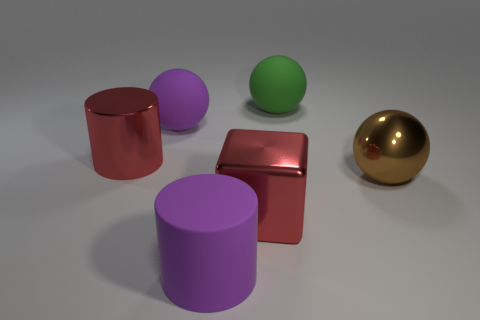Add 4 red cylinders. How many objects exist? 10 Subtract all blocks. How many objects are left? 5 Subtract all big metal cylinders. Subtract all large purple cylinders. How many objects are left? 4 Add 3 brown shiny things. How many brown shiny things are left? 4 Add 6 big shiny things. How many big shiny things exist? 9 Subtract 1 purple spheres. How many objects are left? 5 